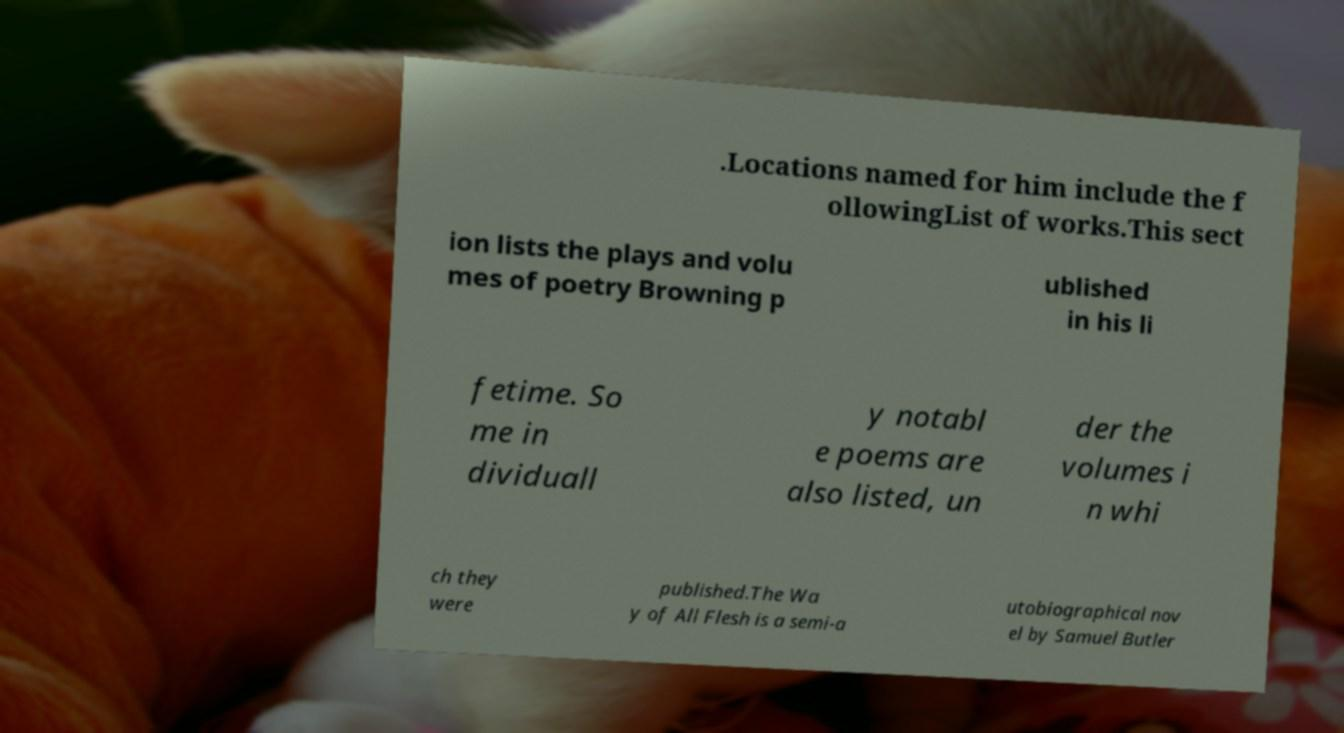Could you extract and type out the text from this image? .Locations named for him include the f ollowingList of works.This sect ion lists the plays and volu mes of poetry Browning p ublished in his li fetime. So me in dividuall y notabl e poems are also listed, un der the volumes i n whi ch they were published.The Wa y of All Flesh is a semi-a utobiographical nov el by Samuel Butler 